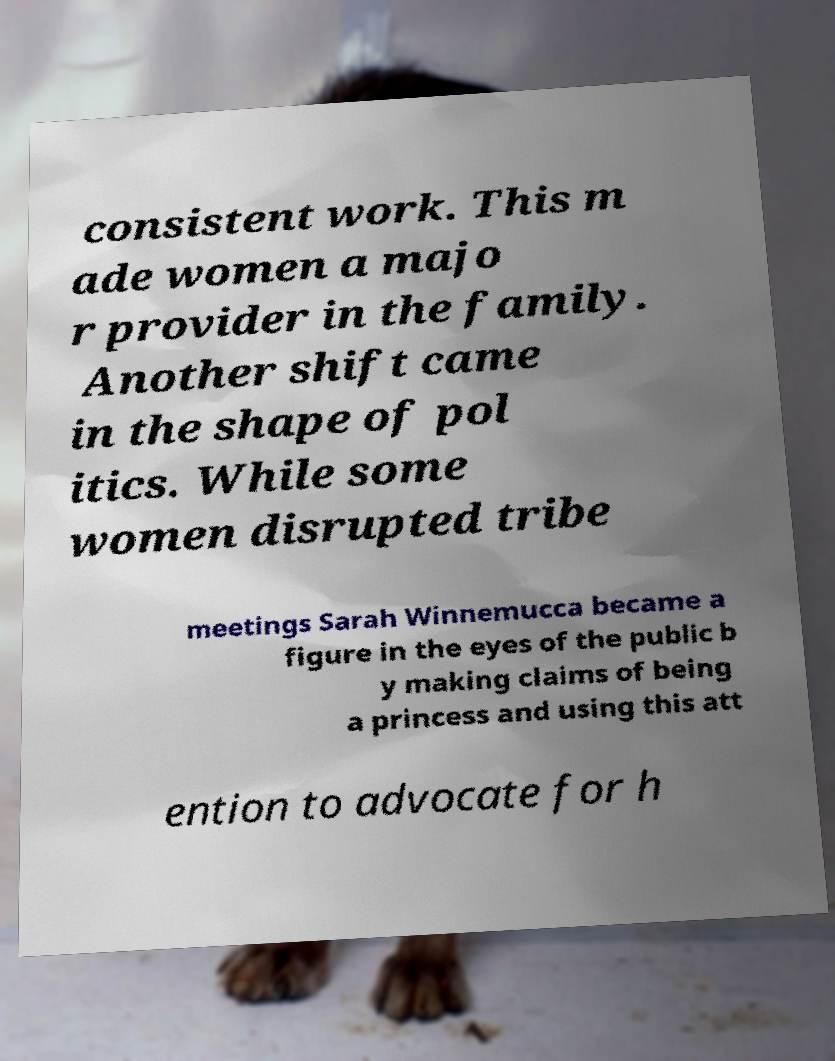Can you accurately transcribe the text from the provided image for me? consistent work. This m ade women a majo r provider in the family. Another shift came in the shape of pol itics. While some women disrupted tribe meetings Sarah Winnemucca became a figure in the eyes of the public b y making claims of being a princess and using this att ention to advocate for h 